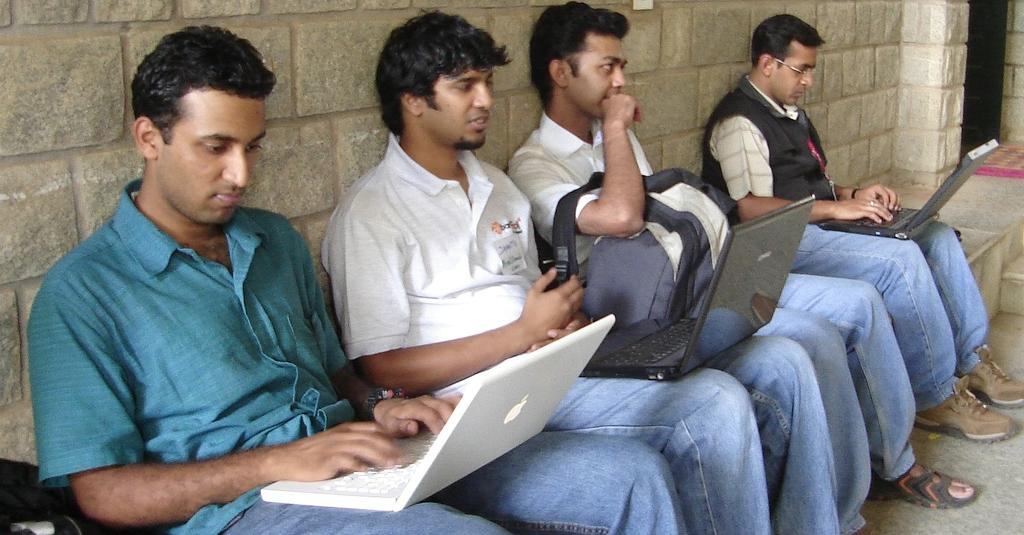How many people are in the image? There are four men in the image. What are the men doing in the image? The men are sitting on a platform. What objects do the men have with them? The men have laptops with them. What can be seen in the background of the image? There is a wall in the background of the image. Are there any plants visible on the platform where the men are sitting? There is no mention of plants in the image; the focus is on the four men and their laptops. 